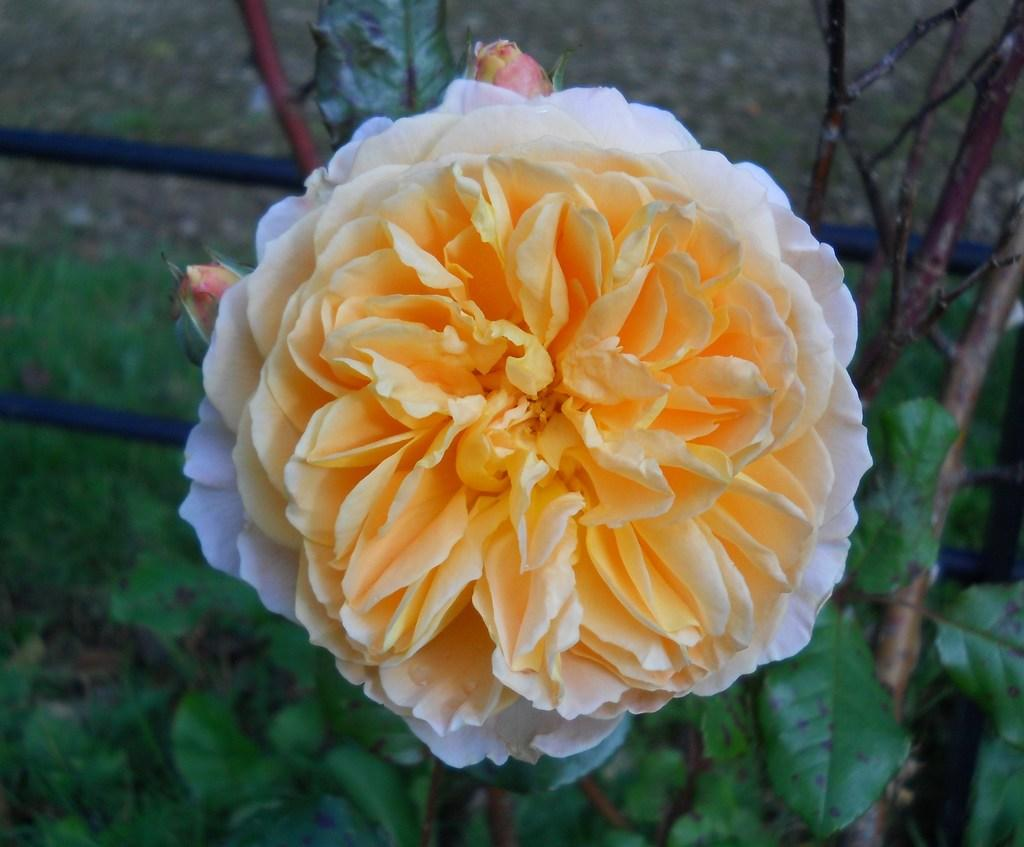What type of living organisms can be seen in the image? Flowers and plants are visible in the image. What material are the rods made of in the image? Metal rods are visible in the image. What type of cream can be seen dripping from the brain in the image? There is no cream or brain present in the image; it features flowers, plants, and metal rods. 